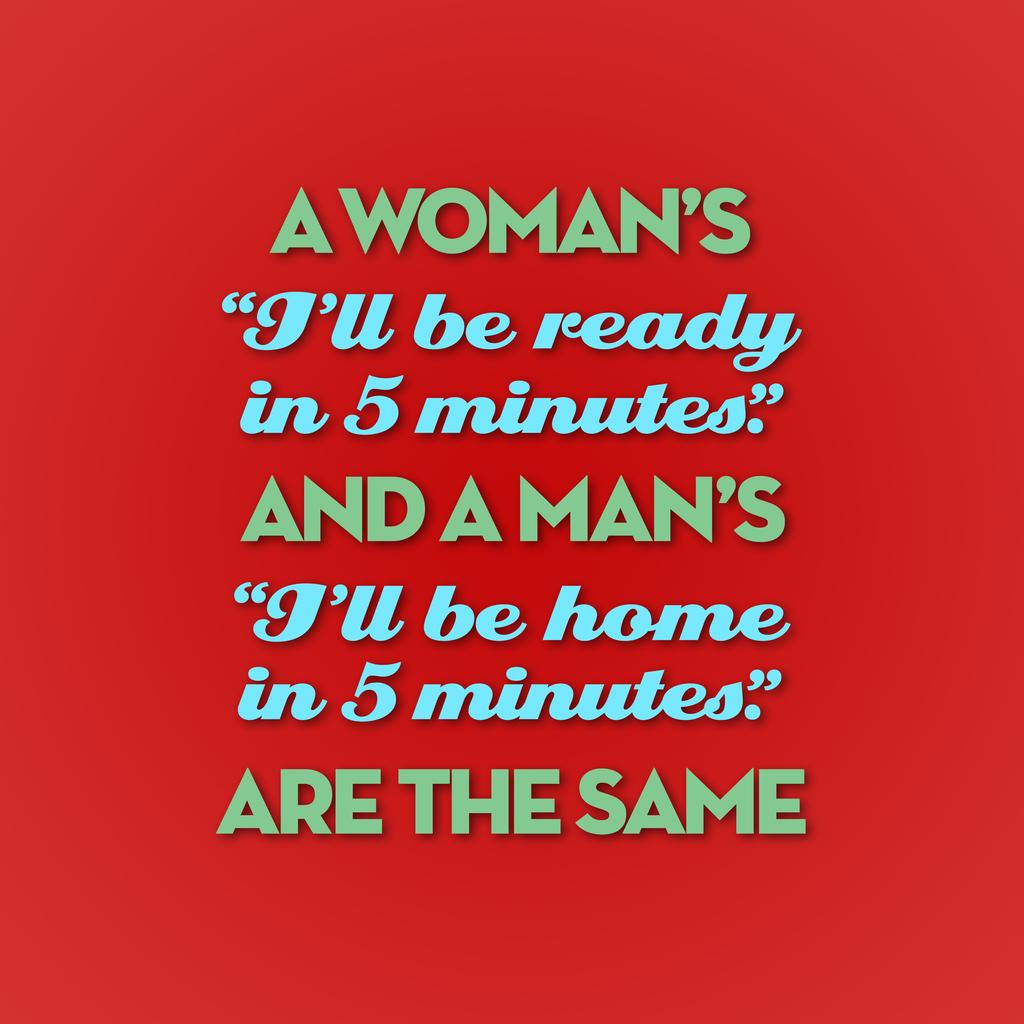What does it say on the top line?
Offer a very short reply. A woman's. 